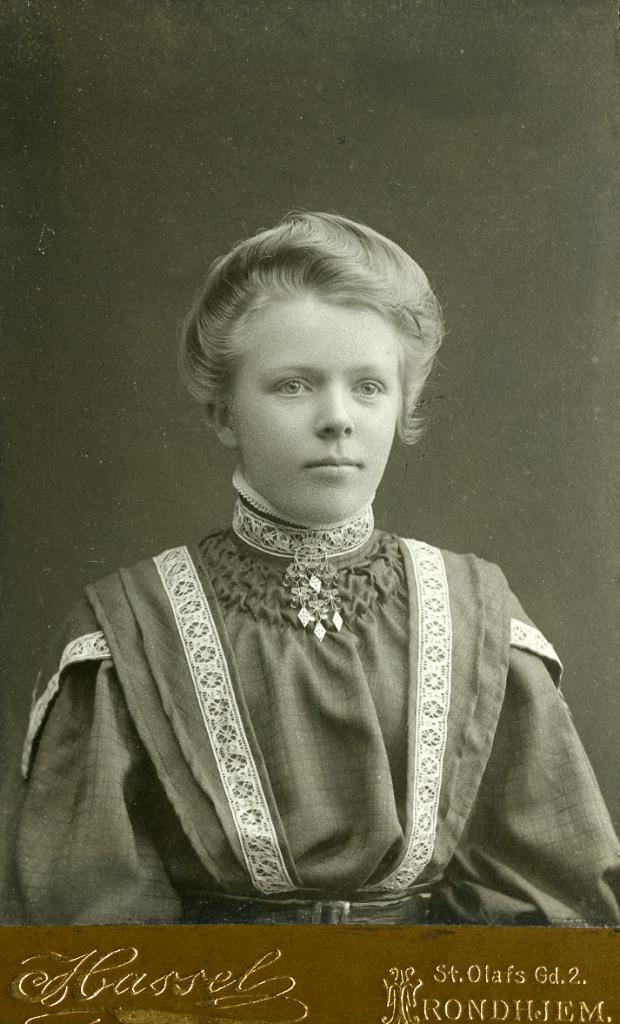How would you summarize this image in a sentence or two? In this image in the center there is one person at the bottom of the image there is some text written, in the background there is wall. 